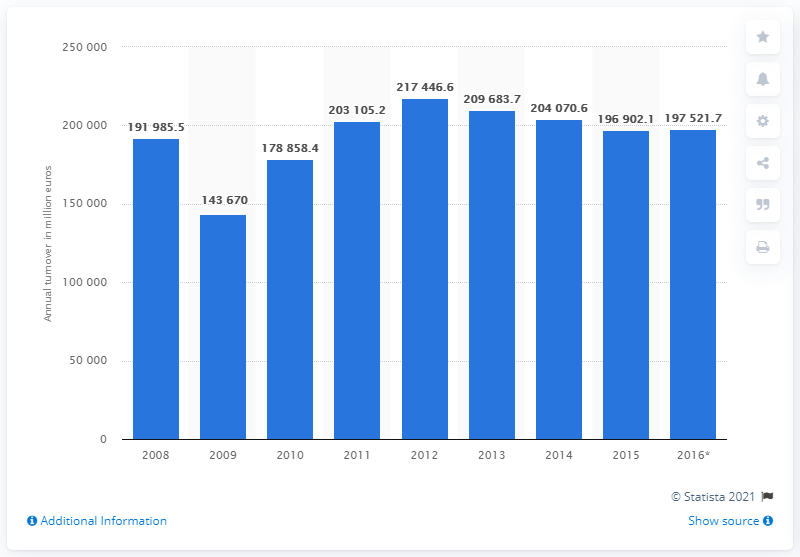Indicate a few pertinent items in this graphic. In 2015, the manufacturing industry in Sweden had a turnover of SEK 197,521.7 million. 